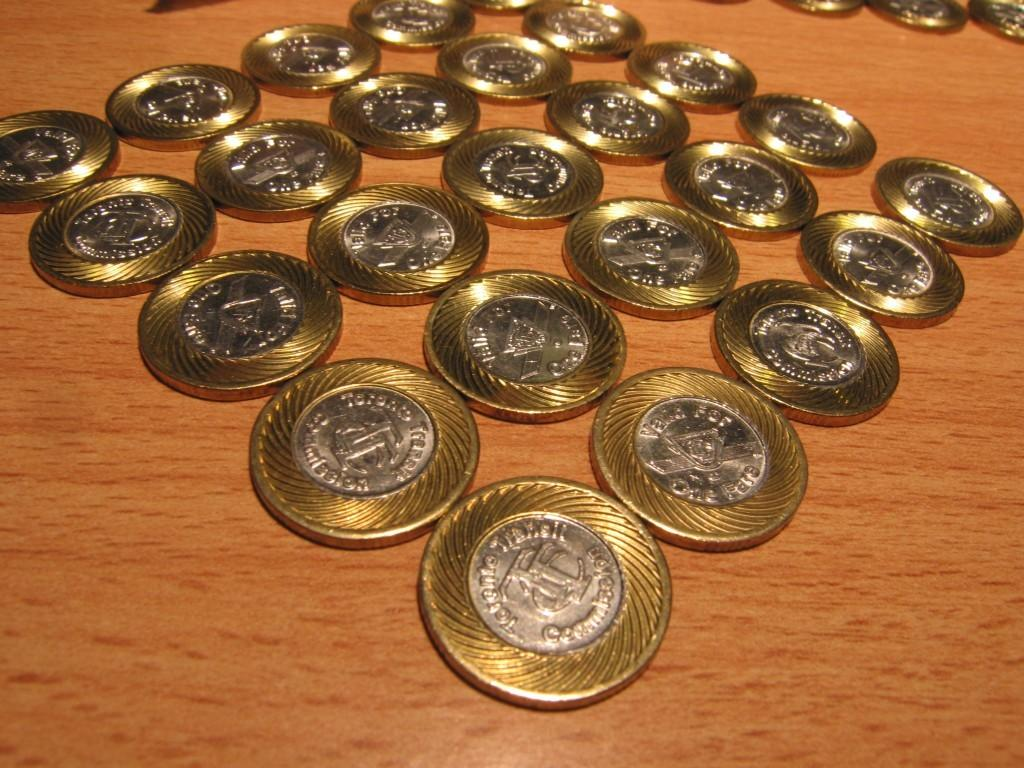What objects are on the wooden surface in the image? There are coins on a wooden surface in the image. What type of surface is the wooden surface? The wooden surface appears to be a table. What type of plants can be seen growing on the table in the image? There are no plants visible on the table in the image; it only features coins on a wooden surface. 